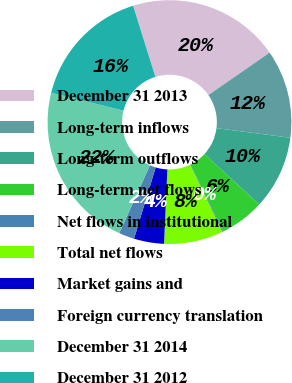<chart> <loc_0><loc_0><loc_500><loc_500><pie_chart><fcel>December 31 2013<fcel>Long-term inflows<fcel>Long-term outflows<fcel>Long-term net flows<fcel>Net flows in institutional<fcel>Total net flows<fcel>Market gains and<fcel>Foreign currency translation<fcel>December 31 2014<fcel>December 31 2012<nl><fcel>20.17%<fcel>11.7%<fcel>9.77%<fcel>5.92%<fcel>0.13%<fcel>7.84%<fcel>3.99%<fcel>2.06%<fcel>22.1%<fcel>16.31%<nl></chart> 